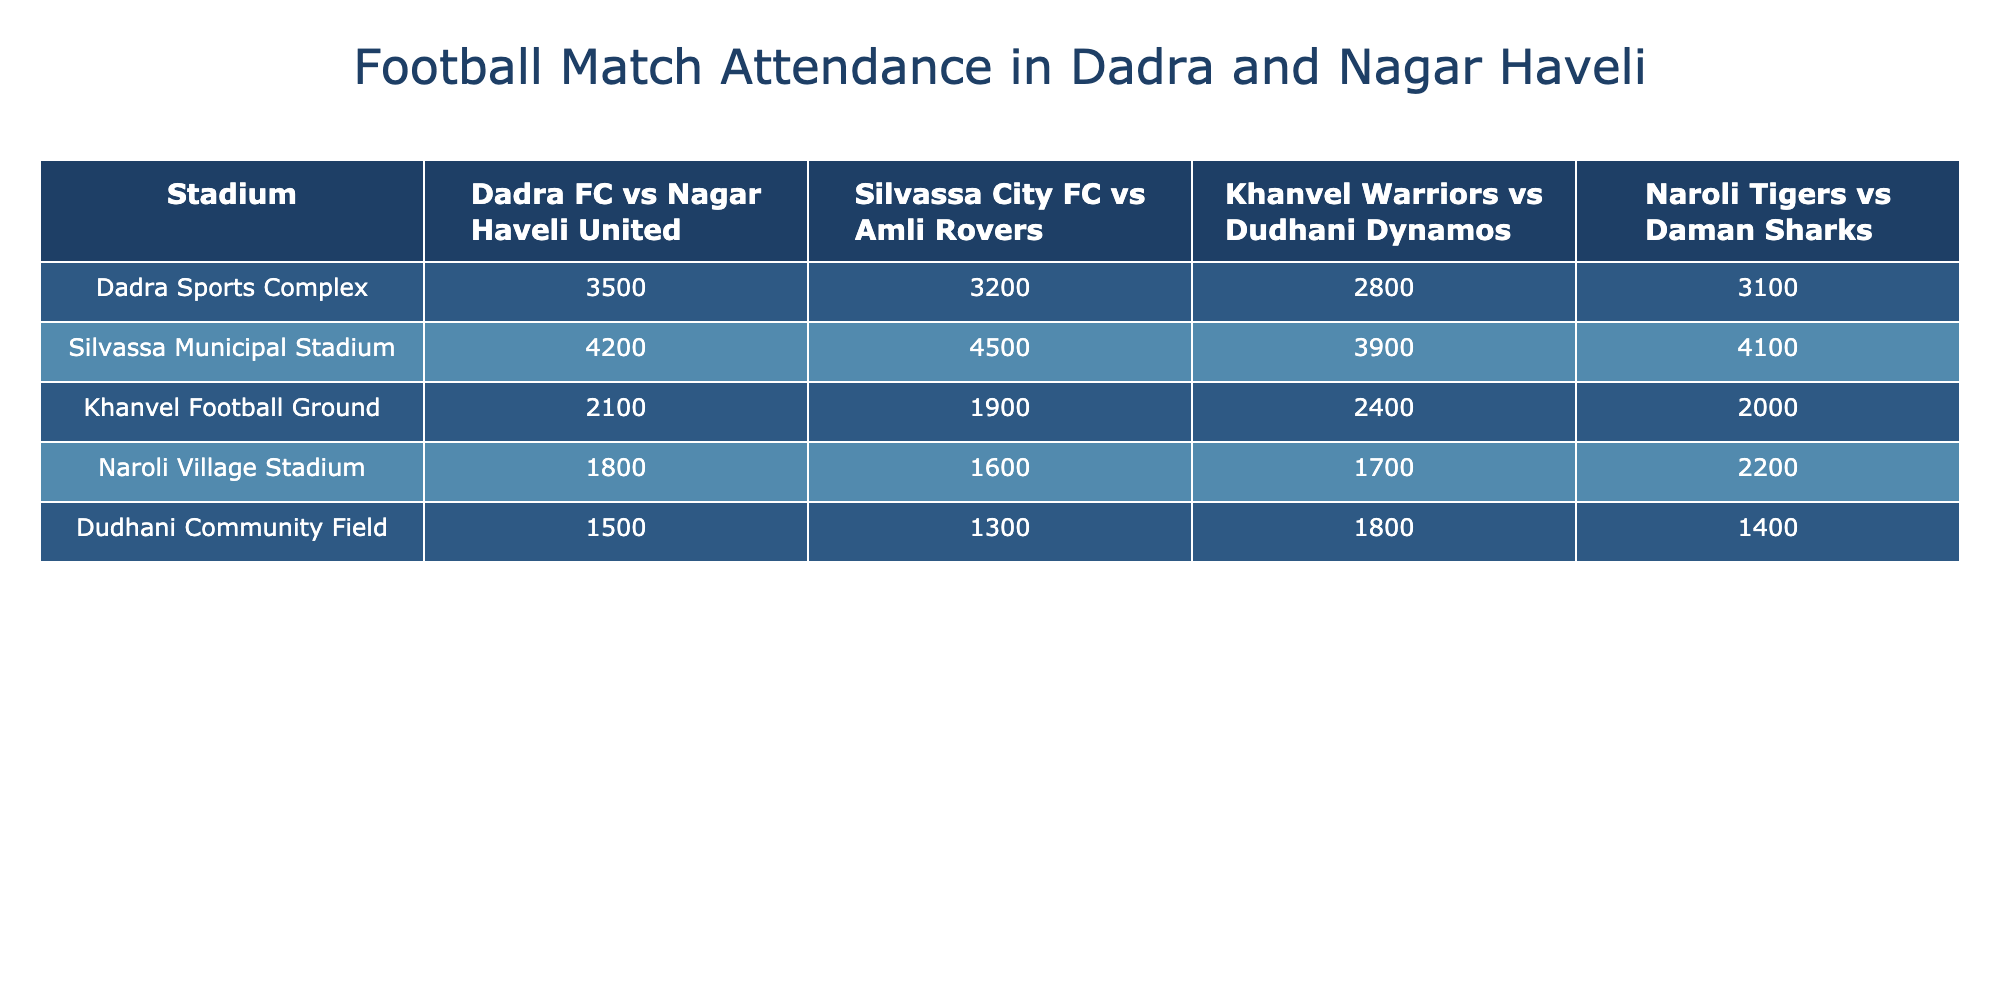What is the highest attendance recorded for a football match at Silvassa Municipal Stadium? The table shows the attendance figures for the matches held at Silvassa Municipal Stadium. The highest attendance value listed is 4500 for the match against Amli Rovers.
Answer: 4500 Which stadium had the lowest attendance for the match between Dadra FC and Nagar Haveli United? By looking at the attendance figures for the match between Dadra FC and Nagar Haveli United, we see that the lowest attendance is at Dudhani Community Field with 1500 attendees.
Answer: 1500 What is the average attendance for the matches played at Khanvel Football Ground? The attendance figures at Khanvel Football Ground are 2100, 1900, 2400, and 2000. First, we sum these numbers: 2100 + 1900 + 2400 + 2000 = 8400. Then, we divide by the number of matches, which is 4: 8400 / 4 = 2100.
Answer: 2100 Did Naroli Village Stadium have a higher attendance for the match against Daman Sharks than Dudhani Community Field did for their match? For Naroli Village Stadium, the attendance for the match against Daman Sharks is 2200, while Dudhani Community Field had 1400 for their match. Therefore, Naroli Village Stadium’s attendance is higher.
Answer: Yes What was the total attendance across all matches held at Dadra Sports Complex? The attendance figures for Dadra Sports Complex are 3500, 3200, 2800, and 3100. To find the total, we add these values: 3500 + 3200 + 2800 + 3100 = 12600.
Answer: 12600 Which stadium had the greatest number of attendees across all matches? By examining the attendance figures for each stadium and comparing the highest values, Silvassa Municipal Stadium has the highest total attendance across its matches: 4200, 4500, 3900, and 4100, which sums to 16700, compared to others.
Answer: Silvassa Municipal Stadium What was the difference in attendance between the highest match at Silvassa Municipal Stadium and the lowest at Dudhani Community Field? The highest attendance at Silvassa Municipal Stadium is 4500, and the lowest at Dudhani Community Field is 1300. The difference is 4500 - 1300 = 3200.
Answer: 3200 Which match drew the most attendees, and what was that attendance? Looking at the table, the match with the highest attendance is Silvassa City FC vs Amli Rovers at Silvassa Municipal Stadium with 4500 attendees.
Answer: Silvassa City FC vs Amli Rovers, 4500 What was the combined attendance for the matches involving Naroli Tigers? The attendance for Naroli Tigers matches are 3100 (vs Daman Sharks), 2200 (vs Daman Sharks), and 1600 (vs Daman Sharks). Adding these together gives: 3100 + 2200 + 1600 = 6900.
Answer: 6900 